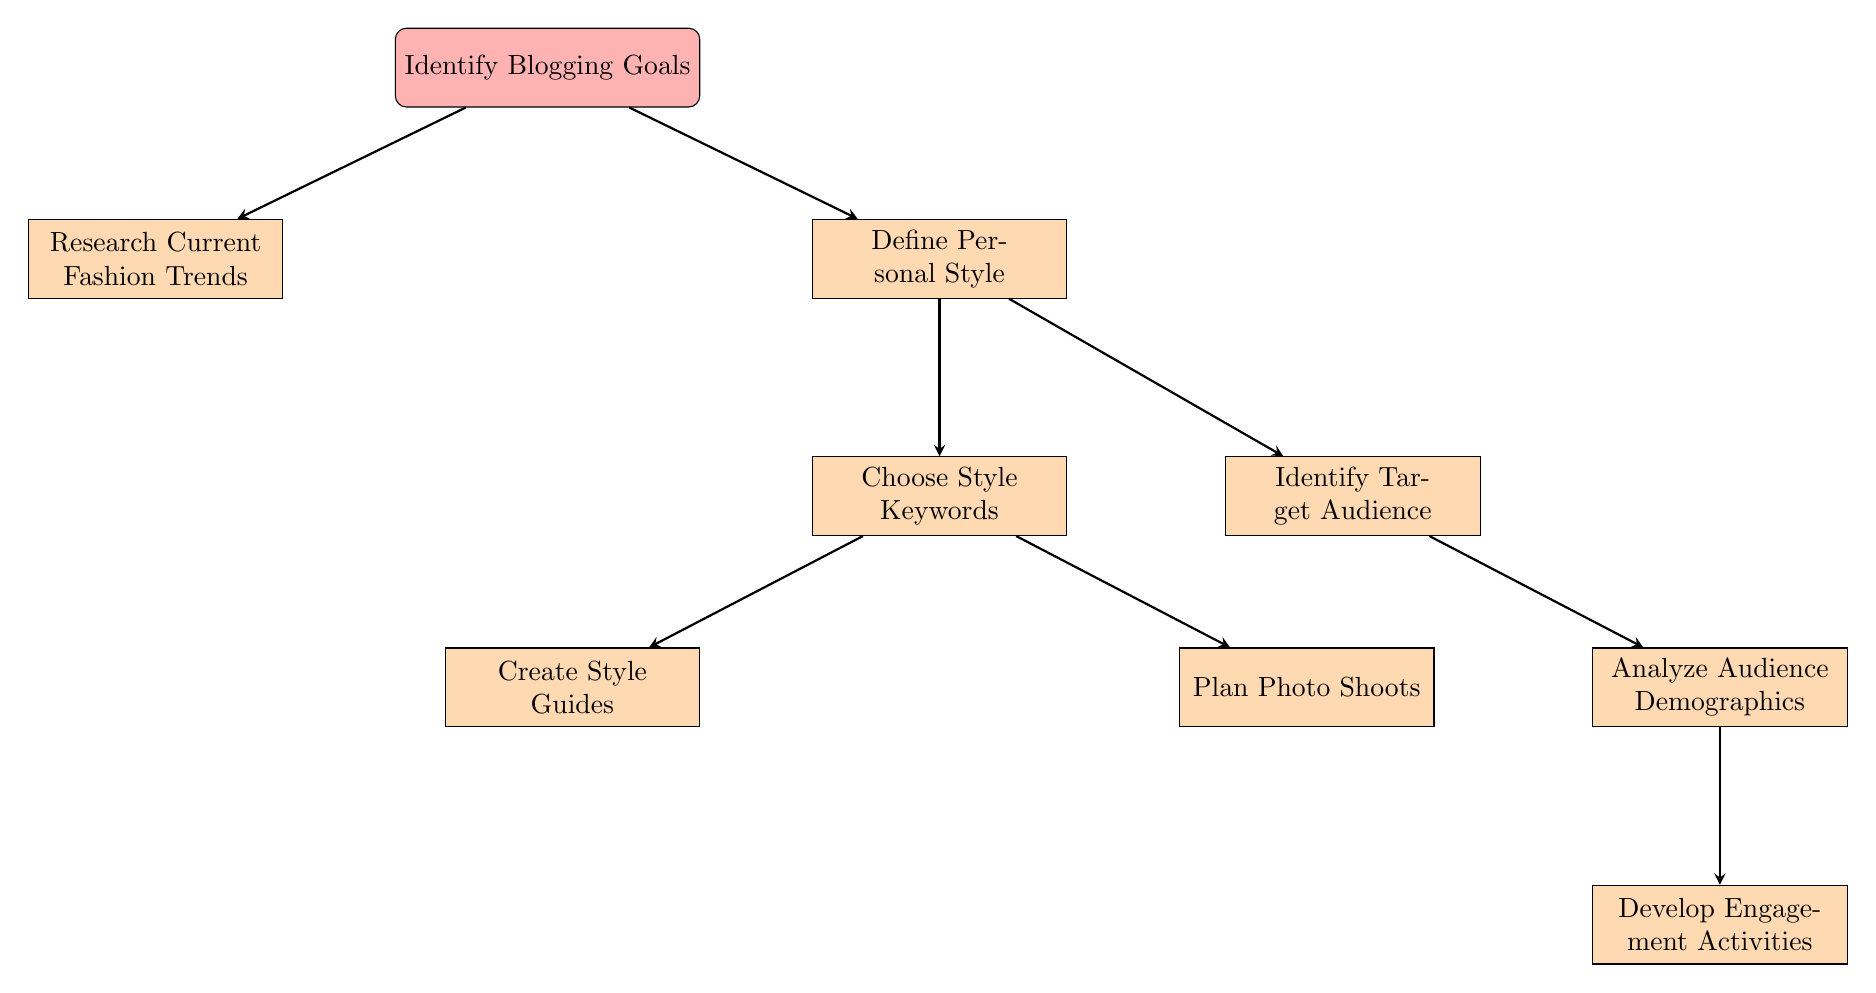What is the first step in the content planning process? The diagram indicates that the first node is "Identify Blogging Goals," which is the starting point of the flowchart.
Answer: Identify Blogging Goals How many main branches follow "Identify Blogging Goals"? From "Identify Blogging Goals," there are two branches that lead to "Research Current Fashion Trends" and "Define Personal Style," so the total is two.
Answer: 2 What is the next step after "Define Personal Style"? Following "Define Personal Style," the flowchart indicates the next step is "Choose Style Keywords." This is a direct connection in the flowchart.
Answer: Choose Style Keywords Which two nodes follow "Choose Style Keywords"? The steps that directly follow "Choose Style Keywords" are "Create Style Guides" and "Plan Photo Shoots," making both of these the subsequent nodes in the flow.
Answer: Create Style Guides and Plan Photo Shoots What node leads to "Analyze Audience Demographics"? The node that leads directly to "Analyze Audience Demographics" is "Identify Target Audience." This indicates that identifying the target audience comes before analyzing demographics.
Answer: Identify Target Audience Which activities are part of the "Develop Engagement Activities"? The diagram indicates that "Develop Engagement Activities" includes "Interaction" (hosting Q&A sessions) and "Collaboration" (partnering with well-known brands), making these the two activities involved.
Answer: Interaction and Collaboration What is necessary before planning photo shoots? The necessary step before "Plan Photo Shoots" is "Choose Style Keywords," as shown in the flowchart where it branches out before reaching the photo shoot planning stage.
Answer: Choose Style Keywords Which node connects "Research Current Fashion Trends" to its next steps? The process connected to "Research Current Fashion Trends" moves towards its next steps, where it branches into "Sources" (following fashion influencers and magazines) and "Analysis" (identifying emerging trends).
Answer: Sources and Analysis 